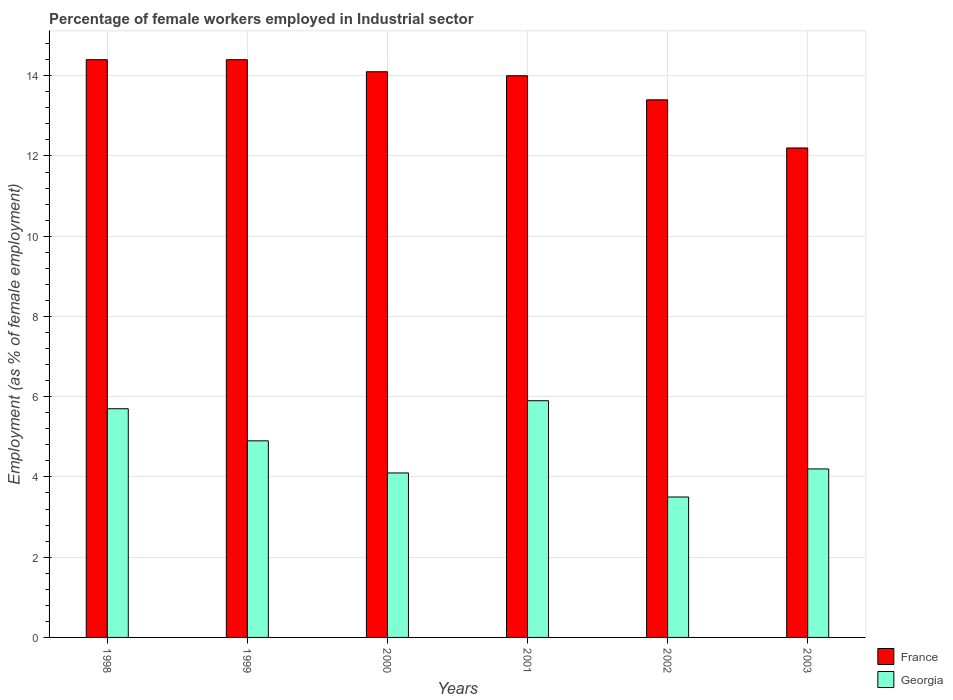How many bars are there on the 3rd tick from the left?
Provide a succinct answer. 2. What is the percentage of females employed in Industrial sector in France in 1998?
Offer a very short reply. 14.4. Across all years, what is the maximum percentage of females employed in Industrial sector in France?
Make the answer very short. 14.4. What is the total percentage of females employed in Industrial sector in France in the graph?
Your response must be concise. 82.5. What is the difference between the percentage of females employed in Industrial sector in France in 2001 and that in 2003?
Provide a succinct answer. 1.8. What is the difference between the percentage of females employed in Industrial sector in Georgia in 2003 and the percentage of females employed in Industrial sector in France in 1998?
Your answer should be compact. -10.2. What is the average percentage of females employed in Industrial sector in Georgia per year?
Make the answer very short. 4.72. In the year 1998, what is the difference between the percentage of females employed in Industrial sector in France and percentage of females employed in Industrial sector in Georgia?
Offer a terse response. 8.7. In how many years, is the percentage of females employed in Industrial sector in Georgia greater than 14.4 %?
Your response must be concise. 0. What is the ratio of the percentage of females employed in Industrial sector in Georgia in 1999 to that in 2001?
Provide a short and direct response. 0.83. Is the percentage of females employed in Industrial sector in France in 1998 less than that in 2002?
Your answer should be compact. No. Is the difference between the percentage of females employed in Industrial sector in France in 2001 and 2003 greater than the difference between the percentage of females employed in Industrial sector in Georgia in 2001 and 2003?
Make the answer very short. Yes. What is the difference between the highest and the second highest percentage of females employed in Industrial sector in Georgia?
Offer a very short reply. 0.2. What is the difference between the highest and the lowest percentage of females employed in Industrial sector in France?
Your response must be concise. 2.2. In how many years, is the percentage of females employed in Industrial sector in France greater than the average percentage of females employed in Industrial sector in France taken over all years?
Your answer should be compact. 4. Is the sum of the percentage of females employed in Industrial sector in France in 2002 and 2003 greater than the maximum percentage of females employed in Industrial sector in Georgia across all years?
Your response must be concise. Yes. What does the 2nd bar from the right in 2002 represents?
Ensure brevity in your answer.  France. How many bars are there?
Offer a terse response. 12. How many years are there in the graph?
Give a very brief answer. 6. What is the difference between two consecutive major ticks on the Y-axis?
Make the answer very short. 2. Are the values on the major ticks of Y-axis written in scientific E-notation?
Give a very brief answer. No. How many legend labels are there?
Ensure brevity in your answer.  2. How are the legend labels stacked?
Your answer should be compact. Vertical. What is the title of the graph?
Keep it short and to the point. Percentage of female workers employed in Industrial sector. What is the label or title of the Y-axis?
Your response must be concise. Employment (as % of female employment). What is the Employment (as % of female employment) in France in 1998?
Give a very brief answer. 14.4. What is the Employment (as % of female employment) in Georgia in 1998?
Make the answer very short. 5.7. What is the Employment (as % of female employment) of France in 1999?
Your response must be concise. 14.4. What is the Employment (as % of female employment) of Georgia in 1999?
Your answer should be very brief. 4.9. What is the Employment (as % of female employment) in France in 2000?
Your answer should be very brief. 14.1. What is the Employment (as % of female employment) in Georgia in 2000?
Your response must be concise. 4.1. What is the Employment (as % of female employment) in France in 2001?
Provide a succinct answer. 14. What is the Employment (as % of female employment) in Georgia in 2001?
Your response must be concise. 5.9. What is the Employment (as % of female employment) of France in 2002?
Give a very brief answer. 13.4. What is the Employment (as % of female employment) of Georgia in 2002?
Offer a very short reply. 3.5. What is the Employment (as % of female employment) of France in 2003?
Provide a short and direct response. 12.2. What is the Employment (as % of female employment) in Georgia in 2003?
Your answer should be compact. 4.2. Across all years, what is the maximum Employment (as % of female employment) of France?
Give a very brief answer. 14.4. Across all years, what is the maximum Employment (as % of female employment) of Georgia?
Give a very brief answer. 5.9. Across all years, what is the minimum Employment (as % of female employment) of France?
Your answer should be very brief. 12.2. Across all years, what is the minimum Employment (as % of female employment) in Georgia?
Keep it short and to the point. 3.5. What is the total Employment (as % of female employment) in France in the graph?
Offer a terse response. 82.5. What is the total Employment (as % of female employment) in Georgia in the graph?
Make the answer very short. 28.3. What is the difference between the Employment (as % of female employment) in France in 1998 and that in 2001?
Ensure brevity in your answer.  0.4. What is the difference between the Employment (as % of female employment) of Georgia in 1998 and that in 2001?
Offer a terse response. -0.2. What is the difference between the Employment (as % of female employment) of France in 1999 and that in 2000?
Your response must be concise. 0.3. What is the difference between the Employment (as % of female employment) of Georgia in 1999 and that in 2000?
Keep it short and to the point. 0.8. What is the difference between the Employment (as % of female employment) of France in 1999 and that in 2001?
Offer a terse response. 0.4. What is the difference between the Employment (as % of female employment) of France in 1999 and that in 2002?
Make the answer very short. 1. What is the difference between the Employment (as % of female employment) of Georgia in 1999 and that in 2002?
Your answer should be very brief. 1.4. What is the difference between the Employment (as % of female employment) of Georgia in 1999 and that in 2003?
Provide a short and direct response. 0.7. What is the difference between the Employment (as % of female employment) in France in 2000 and that in 2001?
Your answer should be very brief. 0.1. What is the difference between the Employment (as % of female employment) in Georgia in 2000 and that in 2001?
Your answer should be very brief. -1.8. What is the difference between the Employment (as % of female employment) in France in 2000 and that in 2002?
Keep it short and to the point. 0.7. What is the difference between the Employment (as % of female employment) of France in 2000 and that in 2003?
Your answer should be very brief. 1.9. What is the difference between the Employment (as % of female employment) in France in 2001 and that in 2002?
Provide a short and direct response. 0.6. What is the difference between the Employment (as % of female employment) of Georgia in 2001 and that in 2003?
Keep it short and to the point. 1.7. What is the difference between the Employment (as % of female employment) in Georgia in 2002 and that in 2003?
Make the answer very short. -0.7. What is the difference between the Employment (as % of female employment) in France in 1998 and the Employment (as % of female employment) in Georgia in 1999?
Provide a succinct answer. 9.5. What is the difference between the Employment (as % of female employment) of France in 1998 and the Employment (as % of female employment) of Georgia in 2002?
Make the answer very short. 10.9. What is the difference between the Employment (as % of female employment) in France in 1999 and the Employment (as % of female employment) in Georgia in 2001?
Ensure brevity in your answer.  8.5. What is the difference between the Employment (as % of female employment) of France in 1999 and the Employment (as % of female employment) of Georgia in 2003?
Make the answer very short. 10.2. What is the difference between the Employment (as % of female employment) in France in 2000 and the Employment (as % of female employment) in Georgia in 2001?
Provide a succinct answer. 8.2. What is the difference between the Employment (as % of female employment) in France in 2000 and the Employment (as % of female employment) in Georgia in 2003?
Ensure brevity in your answer.  9.9. What is the difference between the Employment (as % of female employment) in France in 2001 and the Employment (as % of female employment) in Georgia in 2003?
Provide a succinct answer. 9.8. What is the difference between the Employment (as % of female employment) of France in 2002 and the Employment (as % of female employment) of Georgia in 2003?
Make the answer very short. 9.2. What is the average Employment (as % of female employment) in France per year?
Provide a short and direct response. 13.75. What is the average Employment (as % of female employment) of Georgia per year?
Ensure brevity in your answer.  4.72. In the year 1998, what is the difference between the Employment (as % of female employment) of France and Employment (as % of female employment) of Georgia?
Ensure brevity in your answer.  8.7. In the year 2000, what is the difference between the Employment (as % of female employment) of France and Employment (as % of female employment) of Georgia?
Keep it short and to the point. 10. In the year 2001, what is the difference between the Employment (as % of female employment) of France and Employment (as % of female employment) of Georgia?
Ensure brevity in your answer.  8.1. In the year 2002, what is the difference between the Employment (as % of female employment) in France and Employment (as % of female employment) in Georgia?
Offer a very short reply. 9.9. What is the ratio of the Employment (as % of female employment) in Georgia in 1998 to that in 1999?
Your answer should be very brief. 1.16. What is the ratio of the Employment (as % of female employment) of France in 1998 to that in 2000?
Offer a terse response. 1.02. What is the ratio of the Employment (as % of female employment) in Georgia in 1998 to that in 2000?
Give a very brief answer. 1.39. What is the ratio of the Employment (as % of female employment) in France in 1998 to that in 2001?
Provide a short and direct response. 1.03. What is the ratio of the Employment (as % of female employment) in Georgia in 1998 to that in 2001?
Your answer should be compact. 0.97. What is the ratio of the Employment (as % of female employment) of France in 1998 to that in 2002?
Provide a succinct answer. 1.07. What is the ratio of the Employment (as % of female employment) in Georgia in 1998 to that in 2002?
Keep it short and to the point. 1.63. What is the ratio of the Employment (as % of female employment) in France in 1998 to that in 2003?
Your response must be concise. 1.18. What is the ratio of the Employment (as % of female employment) in Georgia in 1998 to that in 2003?
Make the answer very short. 1.36. What is the ratio of the Employment (as % of female employment) in France in 1999 to that in 2000?
Provide a succinct answer. 1.02. What is the ratio of the Employment (as % of female employment) in Georgia in 1999 to that in 2000?
Your response must be concise. 1.2. What is the ratio of the Employment (as % of female employment) of France in 1999 to that in 2001?
Provide a succinct answer. 1.03. What is the ratio of the Employment (as % of female employment) of Georgia in 1999 to that in 2001?
Make the answer very short. 0.83. What is the ratio of the Employment (as % of female employment) of France in 1999 to that in 2002?
Keep it short and to the point. 1.07. What is the ratio of the Employment (as % of female employment) in Georgia in 1999 to that in 2002?
Give a very brief answer. 1.4. What is the ratio of the Employment (as % of female employment) of France in 1999 to that in 2003?
Offer a terse response. 1.18. What is the ratio of the Employment (as % of female employment) of France in 2000 to that in 2001?
Provide a succinct answer. 1.01. What is the ratio of the Employment (as % of female employment) of Georgia in 2000 to that in 2001?
Offer a terse response. 0.69. What is the ratio of the Employment (as % of female employment) of France in 2000 to that in 2002?
Make the answer very short. 1.05. What is the ratio of the Employment (as % of female employment) of Georgia in 2000 to that in 2002?
Your answer should be very brief. 1.17. What is the ratio of the Employment (as % of female employment) of France in 2000 to that in 2003?
Your answer should be very brief. 1.16. What is the ratio of the Employment (as % of female employment) of Georgia in 2000 to that in 2003?
Provide a succinct answer. 0.98. What is the ratio of the Employment (as % of female employment) of France in 2001 to that in 2002?
Give a very brief answer. 1.04. What is the ratio of the Employment (as % of female employment) of Georgia in 2001 to that in 2002?
Keep it short and to the point. 1.69. What is the ratio of the Employment (as % of female employment) in France in 2001 to that in 2003?
Make the answer very short. 1.15. What is the ratio of the Employment (as % of female employment) of Georgia in 2001 to that in 2003?
Make the answer very short. 1.4. What is the ratio of the Employment (as % of female employment) of France in 2002 to that in 2003?
Keep it short and to the point. 1.1. What is the difference between the highest and the second highest Employment (as % of female employment) in France?
Offer a very short reply. 0. What is the difference between the highest and the lowest Employment (as % of female employment) of France?
Ensure brevity in your answer.  2.2. What is the difference between the highest and the lowest Employment (as % of female employment) of Georgia?
Your answer should be compact. 2.4. 